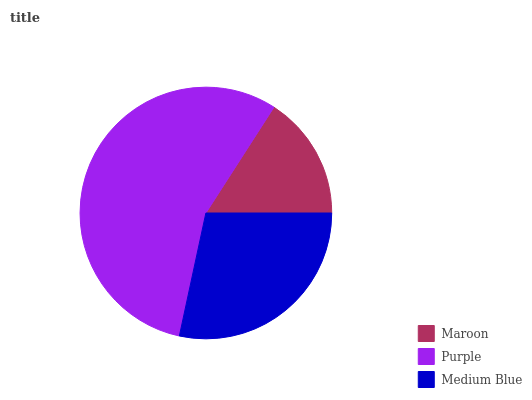Is Maroon the minimum?
Answer yes or no. Yes. Is Purple the maximum?
Answer yes or no. Yes. Is Medium Blue the minimum?
Answer yes or no. No. Is Medium Blue the maximum?
Answer yes or no. No. Is Purple greater than Medium Blue?
Answer yes or no. Yes. Is Medium Blue less than Purple?
Answer yes or no. Yes. Is Medium Blue greater than Purple?
Answer yes or no. No. Is Purple less than Medium Blue?
Answer yes or no. No. Is Medium Blue the high median?
Answer yes or no. Yes. Is Medium Blue the low median?
Answer yes or no. Yes. Is Maroon the high median?
Answer yes or no. No. Is Purple the low median?
Answer yes or no. No. 